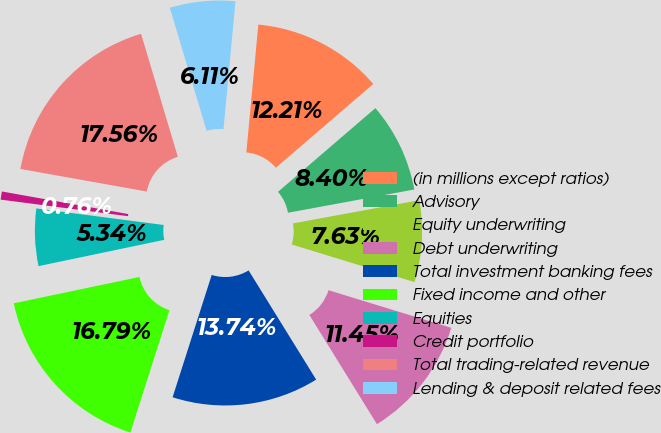<chart> <loc_0><loc_0><loc_500><loc_500><pie_chart><fcel>(in millions except ratios)<fcel>Advisory<fcel>Equity underwriting<fcel>Debt underwriting<fcel>Total investment banking fees<fcel>Fixed income and other<fcel>Equities<fcel>Credit portfolio<fcel>Total trading-related revenue<fcel>Lending & deposit related fees<nl><fcel>12.21%<fcel>8.4%<fcel>7.63%<fcel>11.45%<fcel>13.74%<fcel>16.79%<fcel>5.34%<fcel>0.76%<fcel>17.56%<fcel>6.11%<nl></chart> 